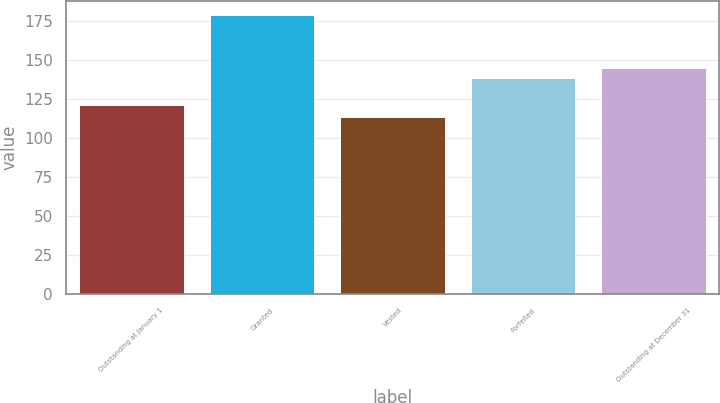Convert chart to OTSL. <chart><loc_0><loc_0><loc_500><loc_500><bar_chart><fcel>Outstanding at January 1<fcel>Granted<fcel>Vested<fcel>Forfeited<fcel>Outstanding at December 31<nl><fcel>120.84<fcel>178.8<fcel>113.12<fcel>138.19<fcel>144.76<nl></chart> 